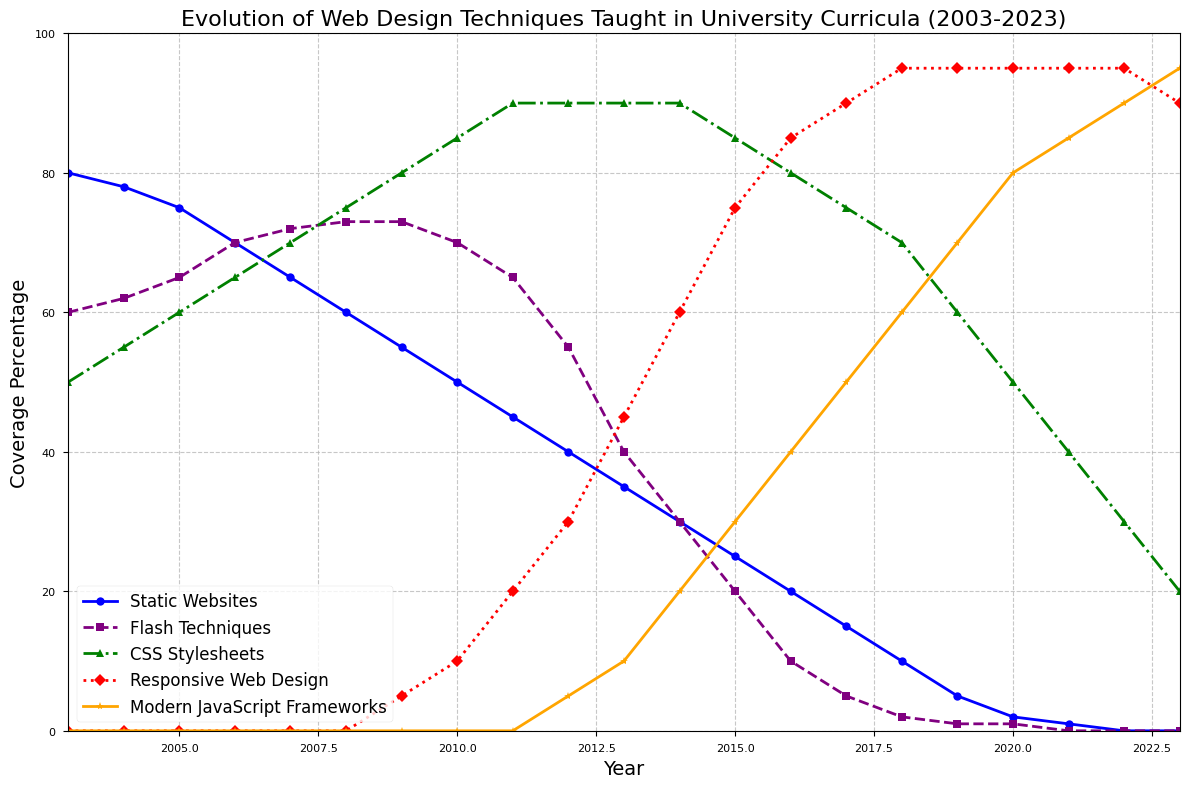What was the percentage coverage of Static Websites in 2003 compared to 2023? In 2003, the coverage of Static Websites is 80%. In 2023, it is 0%. So, the percentage change from 2003 to 2023 is 80% - 0% = 80%.
Answer: 80% Which year did Flash Techniques have the highest coverage, and what was the percentage? By observing the trend line for Flash Techniques, we see it peaked in 2008 with a coverage of 73%.
Answer: 2008, 73% How did the coverage percentage of Modern JavaScript Frameworks change from 2017 to 2023? In 2017, Modern JavaScript Frameworks had a coverage of 50%. By 2023, it increased to 95%. The difference is 95% - 50% = 45%.
Answer: Increased by 45% Compare the coverage percentage of CSS Stylesheets and Responsive Web Design in 2010. Which one had a higher coverage? In 2010, CSS Stylesheets had a coverage of 85%, while Responsive Web Design was at 10%. Therefore, CSS Stylesheets had a higher coverage.
Answer: CSS Stylesheets What is the trend in Responsive Web Design coverage from 2009 to 2023? Starting in 2009 with a coverage of 5%, Responsive Web Design increased rapidly and peaked at 95% from 2015 to 2022 before a slight drop to 90% in 2023.
Answer: Increasing trend In which year did CSS Stylesheets reach a plateau, and what was the coverage percentage during this period? CSS Stylesheets reached a plateau from 2011 to 2014 with a coverage of 90%.
Answer: 2011-2014, 90% When did Flash Techniques disappear from the university curricula? Flash Techniques reached 0% coverage in 2021.
Answer: 2021 What is the average coverage percentage for Static Websites over the 20 years? Summing the coverage percentages for Static Websites from 2003 to 2023 and dividing by 21 years: (80+78+75+70+65+60+55+50+45+40+35+30+25+20+15+10+5+2+1+0+0) / 21 ≈ 32.43%
Answer: 32.43% How does the trend for Modern JavaScript Frameworks compare to the trend for Flash Techniques? Modern JavaScript Frameworks start at 0% in 2003 and continuously grow to 95% in 2023. Flash Techniques start higher in 2003 at 60%, peak at 73% around 2008, and then rapidly decline to 0% by 2021.
Answer: Modern JavaScript Frameworks increasing, Flash Techniques decreasing 